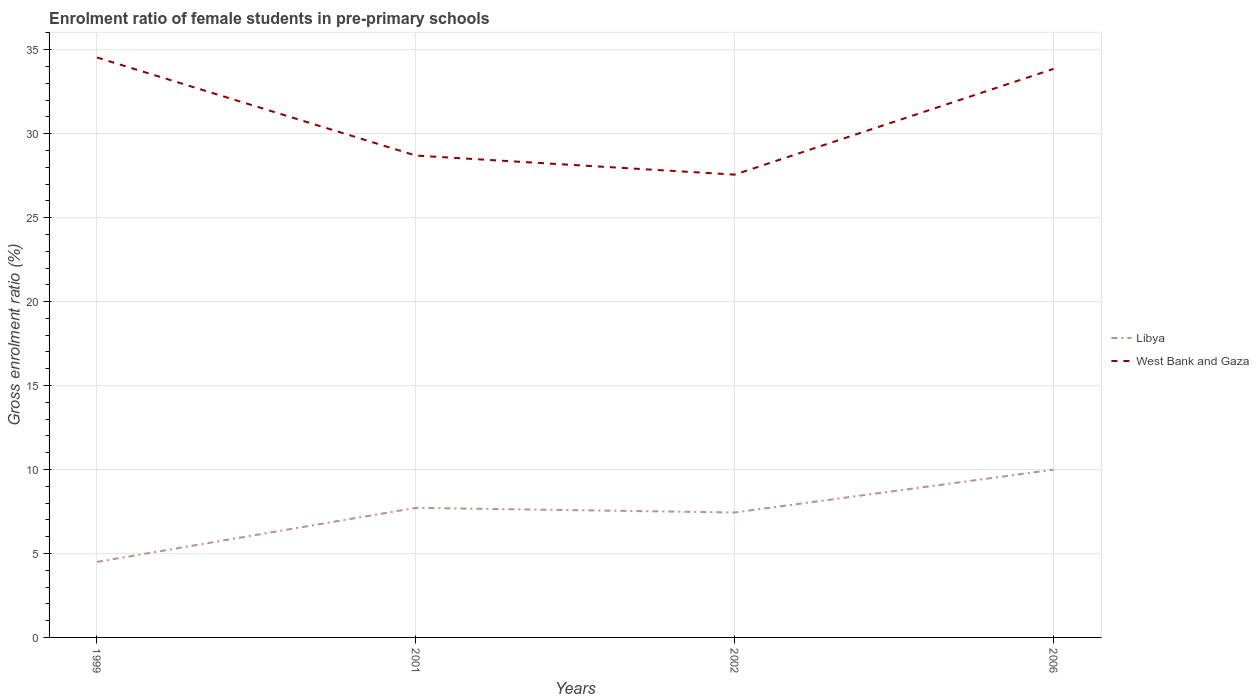Does the line corresponding to Libya intersect with the line corresponding to West Bank and Gaza?
Your response must be concise. No. Across all years, what is the maximum enrolment ratio of female students in pre-primary schools in West Bank and Gaza?
Provide a succinct answer. 27.56. What is the total enrolment ratio of female students in pre-primary schools in West Bank and Gaza in the graph?
Provide a succinct answer. 1.13. What is the difference between the highest and the second highest enrolment ratio of female students in pre-primary schools in West Bank and Gaza?
Provide a short and direct response. 6.98. What is the difference between the highest and the lowest enrolment ratio of female students in pre-primary schools in West Bank and Gaza?
Your answer should be very brief. 2. Is the enrolment ratio of female students in pre-primary schools in Libya strictly greater than the enrolment ratio of female students in pre-primary schools in West Bank and Gaza over the years?
Provide a short and direct response. Yes. How many lines are there?
Your answer should be very brief. 2. What is the difference between two consecutive major ticks on the Y-axis?
Provide a short and direct response. 5. Are the values on the major ticks of Y-axis written in scientific E-notation?
Offer a terse response. No. Does the graph contain any zero values?
Offer a terse response. No. Where does the legend appear in the graph?
Make the answer very short. Center right. What is the title of the graph?
Make the answer very short. Enrolment ratio of female students in pre-primary schools. What is the label or title of the X-axis?
Provide a short and direct response. Years. What is the Gross enrolment ratio (%) in Libya in 1999?
Make the answer very short. 4.5. What is the Gross enrolment ratio (%) in West Bank and Gaza in 1999?
Your answer should be compact. 34.54. What is the Gross enrolment ratio (%) in Libya in 2001?
Offer a very short reply. 7.72. What is the Gross enrolment ratio (%) of West Bank and Gaza in 2001?
Your answer should be compact. 28.7. What is the Gross enrolment ratio (%) of Libya in 2002?
Give a very brief answer. 7.44. What is the Gross enrolment ratio (%) of West Bank and Gaza in 2002?
Keep it short and to the point. 27.56. What is the Gross enrolment ratio (%) of Libya in 2006?
Keep it short and to the point. 9.99. What is the Gross enrolment ratio (%) in West Bank and Gaza in 2006?
Your answer should be compact. 33.86. Across all years, what is the maximum Gross enrolment ratio (%) in Libya?
Provide a short and direct response. 9.99. Across all years, what is the maximum Gross enrolment ratio (%) in West Bank and Gaza?
Offer a terse response. 34.54. Across all years, what is the minimum Gross enrolment ratio (%) of Libya?
Keep it short and to the point. 4.5. Across all years, what is the minimum Gross enrolment ratio (%) of West Bank and Gaza?
Provide a succinct answer. 27.56. What is the total Gross enrolment ratio (%) in Libya in the graph?
Offer a very short reply. 29.65. What is the total Gross enrolment ratio (%) in West Bank and Gaza in the graph?
Offer a terse response. 124.66. What is the difference between the Gross enrolment ratio (%) in Libya in 1999 and that in 2001?
Make the answer very short. -3.22. What is the difference between the Gross enrolment ratio (%) of West Bank and Gaza in 1999 and that in 2001?
Offer a terse response. 5.84. What is the difference between the Gross enrolment ratio (%) in Libya in 1999 and that in 2002?
Make the answer very short. -2.94. What is the difference between the Gross enrolment ratio (%) in West Bank and Gaza in 1999 and that in 2002?
Ensure brevity in your answer.  6.98. What is the difference between the Gross enrolment ratio (%) in Libya in 1999 and that in 2006?
Keep it short and to the point. -5.49. What is the difference between the Gross enrolment ratio (%) in West Bank and Gaza in 1999 and that in 2006?
Keep it short and to the point. 0.68. What is the difference between the Gross enrolment ratio (%) in Libya in 2001 and that in 2002?
Give a very brief answer. 0.28. What is the difference between the Gross enrolment ratio (%) in West Bank and Gaza in 2001 and that in 2002?
Keep it short and to the point. 1.13. What is the difference between the Gross enrolment ratio (%) of Libya in 2001 and that in 2006?
Offer a very short reply. -2.27. What is the difference between the Gross enrolment ratio (%) in West Bank and Gaza in 2001 and that in 2006?
Give a very brief answer. -5.16. What is the difference between the Gross enrolment ratio (%) of Libya in 2002 and that in 2006?
Keep it short and to the point. -2.55. What is the difference between the Gross enrolment ratio (%) in West Bank and Gaza in 2002 and that in 2006?
Keep it short and to the point. -6.3. What is the difference between the Gross enrolment ratio (%) in Libya in 1999 and the Gross enrolment ratio (%) in West Bank and Gaza in 2001?
Provide a short and direct response. -24.2. What is the difference between the Gross enrolment ratio (%) in Libya in 1999 and the Gross enrolment ratio (%) in West Bank and Gaza in 2002?
Provide a short and direct response. -23.06. What is the difference between the Gross enrolment ratio (%) of Libya in 1999 and the Gross enrolment ratio (%) of West Bank and Gaza in 2006?
Your response must be concise. -29.36. What is the difference between the Gross enrolment ratio (%) in Libya in 2001 and the Gross enrolment ratio (%) in West Bank and Gaza in 2002?
Make the answer very short. -19.85. What is the difference between the Gross enrolment ratio (%) of Libya in 2001 and the Gross enrolment ratio (%) of West Bank and Gaza in 2006?
Your response must be concise. -26.14. What is the difference between the Gross enrolment ratio (%) in Libya in 2002 and the Gross enrolment ratio (%) in West Bank and Gaza in 2006?
Offer a terse response. -26.42. What is the average Gross enrolment ratio (%) in Libya per year?
Your answer should be compact. 7.41. What is the average Gross enrolment ratio (%) of West Bank and Gaza per year?
Provide a succinct answer. 31.16. In the year 1999, what is the difference between the Gross enrolment ratio (%) of Libya and Gross enrolment ratio (%) of West Bank and Gaza?
Your answer should be very brief. -30.04. In the year 2001, what is the difference between the Gross enrolment ratio (%) of Libya and Gross enrolment ratio (%) of West Bank and Gaza?
Give a very brief answer. -20.98. In the year 2002, what is the difference between the Gross enrolment ratio (%) in Libya and Gross enrolment ratio (%) in West Bank and Gaza?
Provide a succinct answer. -20.12. In the year 2006, what is the difference between the Gross enrolment ratio (%) in Libya and Gross enrolment ratio (%) in West Bank and Gaza?
Ensure brevity in your answer.  -23.87. What is the ratio of the Gross enrolment ratio (%) of Libya in 1999 to that in 2001?
Provide a short and direct response. 0.58. What is the ratio of the Gross enrolment ratio (%) of West Bank and Gaza in 1999 to that in 2001?
Provide a short and direct response. 1.2. What is the ratio of the Gross enrolment ratio (%) of Libya in 1999 to that in 2002?
Your answer should be very brief. 0.6. What is the ratio of the Gross enrolment ratio (%) in West Bank and Gaza in 1999 to that in 2002?
Your response must be concise. 1.25. What is the ratio of the Gross enrolment ratio (%) in Libya in 1999 to that in 2006?
Make the answer very short. 0.45. What is the ratio of the Gross enrolment ratio (%) of West Bank and Gaza in 1999 to that in 2006?
Keep it short and to the point. 1.02. What is the ratio of the Gross enrolment ratio (%) in Libya in 2001 to that in 2002?
Keep it short and to the point. 1.04. What is the ratio of the Gross enrolment ratio (%) of West Bank and Gaza in 2001 to that in 2002?
Provide a succinct answer. 1.04. What is the ratio of the Gross enrolment ratio (%) of Libya in 2001 to that in 2006?
Give a very brief answer. 0.77. What is the ratio of the Gross enrolment ratio (%) of West Bank and Gaza in 2001 to that in 2006?
Provide a short and direct response. 0.85. What is the ratio of the Gross enrolment ratio (%) of Libya in 2002 to that in 2006?
Offer a very short reply. 0.74. What is the ratio of the Gross enrolment ratio (%) in West Bank and Gaza in 2002 to that in 2006?
Provide a succinct answer. 0.81. What is the difference between the highest and the second highest Gross enrolment ratio (%) in Libya?
Ensure brevity in your answer.  2.27. What is the difference between the highest and the second highest Gross enrolment ratio (%) of West Bank and Gaza?
Give a very brief answer. 0.68. What is the difference between the highest and the lowest Gross enrolment ratio (%) in Libya?
Offer a very short reply. 5.49. What is the difference between the highest and the lowest Gross enrolment ratio (%) in West Bank and Gaza?
Provide a succinct answer. 6.98. 